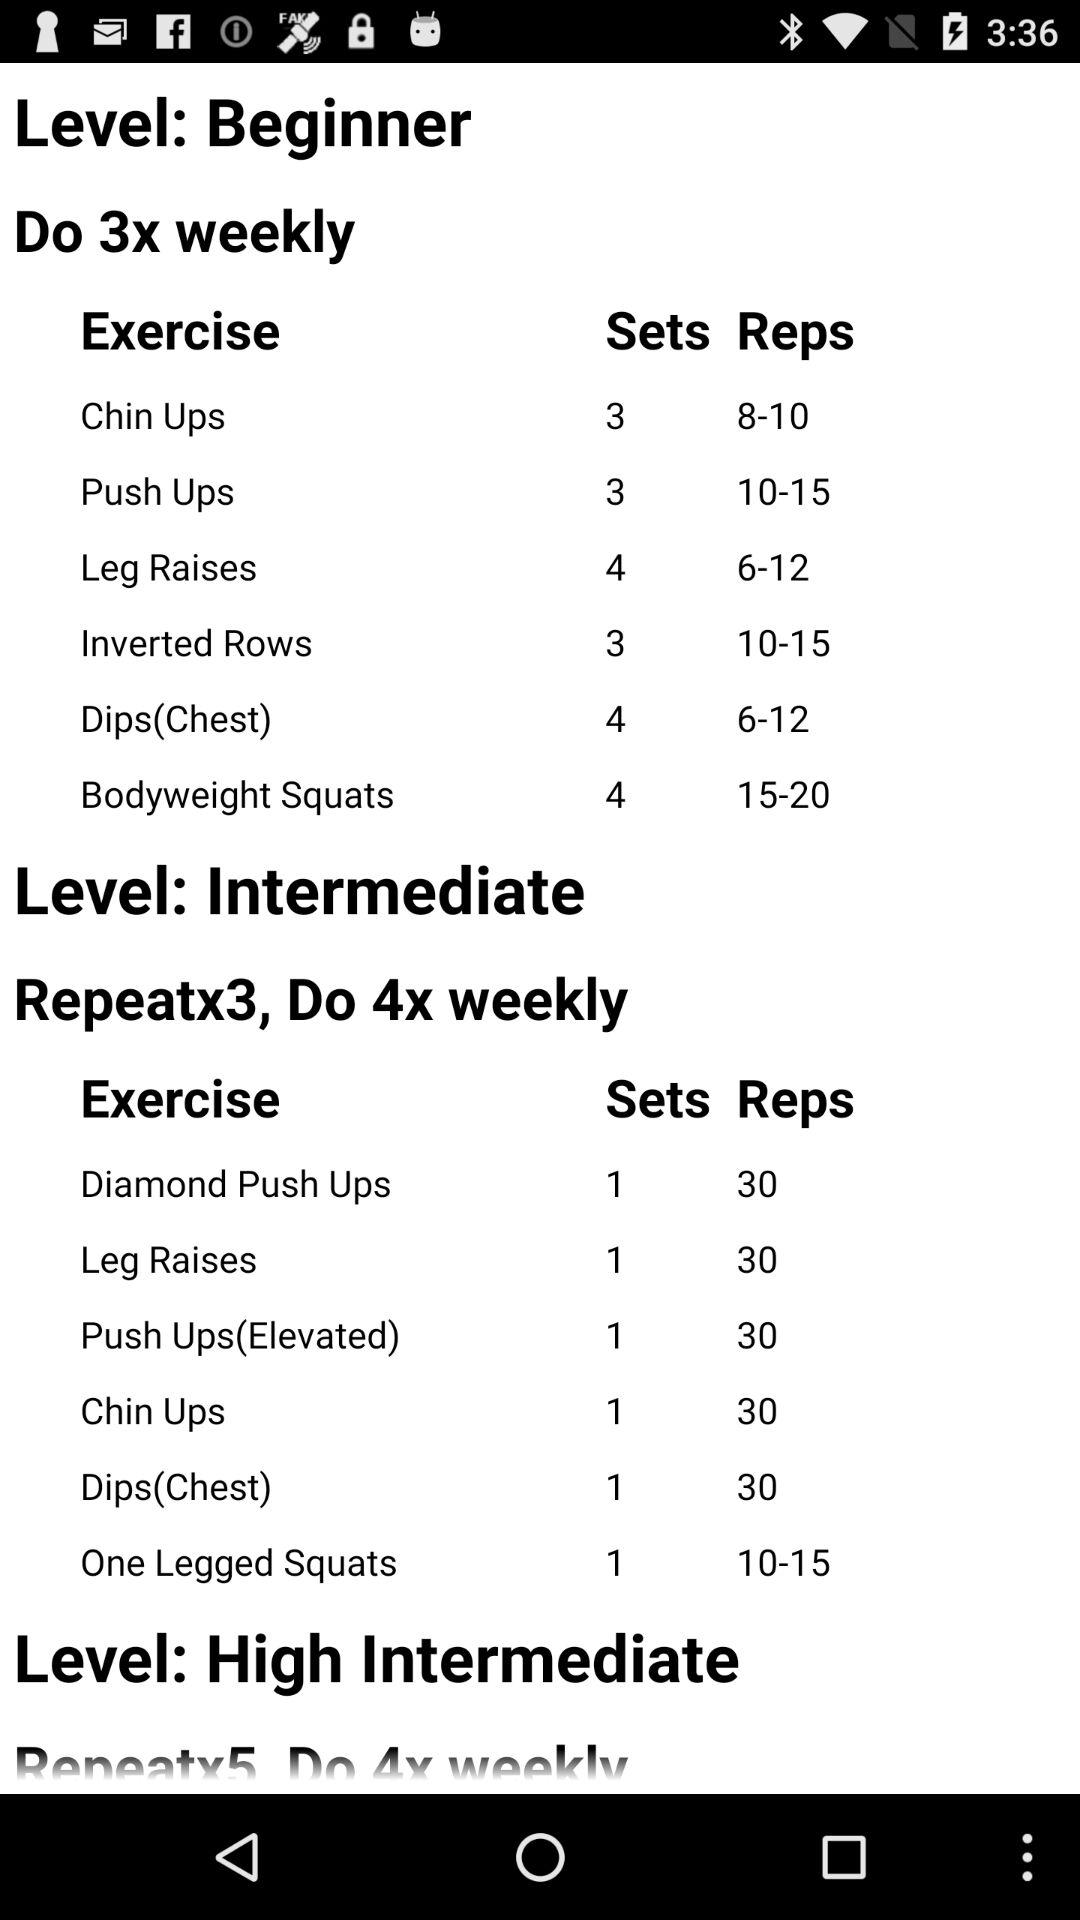How many sets of dips should we do at the beginner level? You should do 4 sets of dips at the beginner level. 